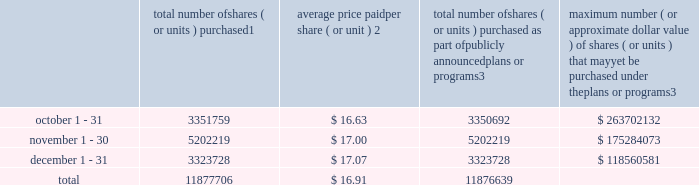Transfer agent and registrar for common stock the transfer agent and registrar for our common stock is : computershare shareowner services llc 480 washington boulevard 29th floor jersey city , new jersey 07310 telephone : ( 877 ) 363-6398 sales of unregistered securities not applicable .
Repurchase of equity securities the table provides information regarding our purchases of our equity securities during the period from october 1 , 2013 to december 31 , 2013 .
Total number of shares ( or units ) purchased 1 average price paid per share ( or unit ) 2 total number of shares ( or units ) purchased as part of publicly announced plans or programs 3 maximum number ( or approximate dollar value ) of shares ( or units ) that may yet be purchased under the plans or programs 3 .
1 includes shares of our common stock , par value $ 0.10 per share , withheld under the terms of grants under employee stock-based compensation plans to offset tax withholding obligations that occurred upon vesting and release of restricted shares ( the 201cwithheld shares 201d ) .
We repurchased 1067 withheld shares in october 2013 .
No withheld shares were purchased in november or december of 2013 .
2 the average price per share for each of the months in the fiscal quarter and for the three-month period was calculated by dividing the sum of the applicable period of the aggregate value of the tax withholding obligations and the aggregate amount we paid for shares acquired under our stock repurchase program , described in note 6 to the consolidated financial statements , by the sum of the number of withheld shares and the number of shares acquired in our stock repurchase program .
3 in february 2013 , the board authorized a new share repurchase program to repurchase from time to time up to $ 300.0 million , excluding fees , of our common stock ( the 201c2013 share repurchase program 201d ) .
In march 2013 , the board authorized an increase in the amount available under our 2013 share repurchase program up to $ 500.0 million , excluding fees , of our common stock .
On february 14 , 2014 , we announced that our board had approved a new share repurchase program to repurchase from time to time up to $ 300.0 million , excluding fees , of our common stock .
The new authorization is in addition to any amounts remaining available for repurchase under the 2013 share repurchase program .
There is no expiration date associated with the share repurchase programs. .
By what amount did the treasury stock increase with the total repurchase of shares during the last three months , ( in millions ) ? 
Computations: ((11877706 * 16.91) / 1000000)
Answer: 200.85201. 